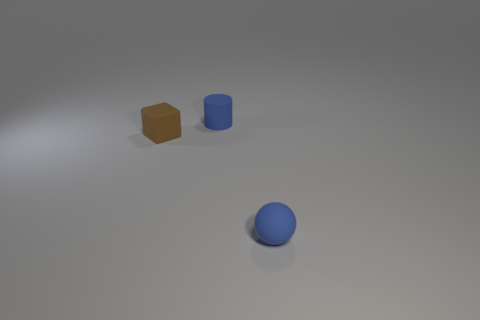How many other objects are there of the same color as the small sphere?
Your answer should be compact. 1. Are there any matte cubes right of the block?
Your answer should be compact. No. How many objects are either small blue rubber spheres or small blue spheres to the right of the tiny blue cylinder?
Your response must be concise. 1. There is a blue rubber object in front of the small blue matte cylinder; is there a tiny brown block to the left of it?
Give a very brief answer. Yes. There is a small blue object that is on the right side of the blue matte object that is to the left of the blue object that is in front of the matte cylinder; what shape is it?
Keep it short and to the point. Sphere. What is the color of the rubber thing that is in front of the cylinder and behind the rubber ball?
Offer a very short reply. Brown. The small blue thing that is to the left of the blue ball has what shape?
Make the answer very short. Cylinder. The brown object that is the same material as the cylinder is what shape?
Your answer should be compact. Cube. How many rubber objects are small gray things or tiny brown objects?
Your answer should be very brief. 1. There is a blue thing on the left side of the matte sphere that is on the right side of the cube; what number of objects are left of it?
Provide a short and direct response. 1. 